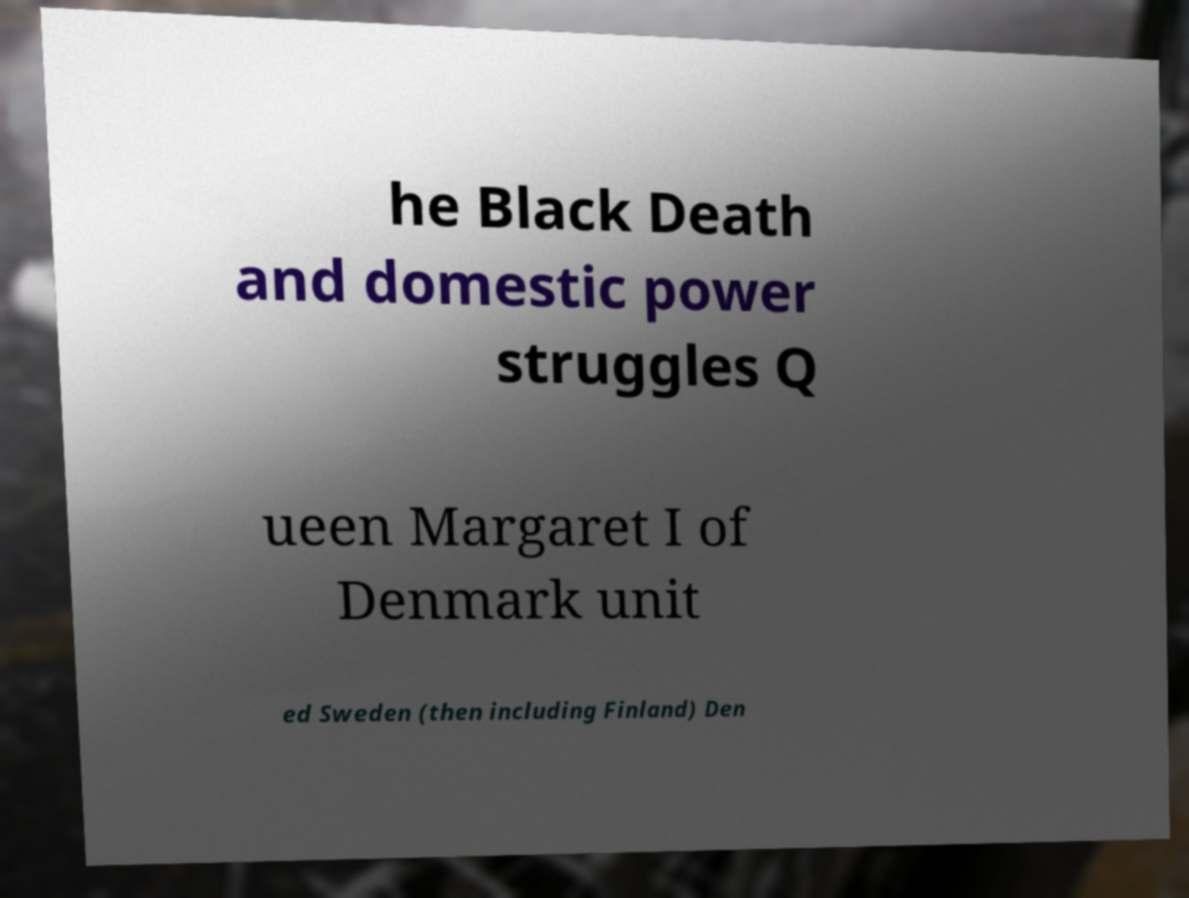For documentation purposes, I need the text within this image transcribed. Could you provide that? he Black Death and domestic power struggles Q ueen Margaret I of Denmark unit ed Sweden (then including Finland) Den 